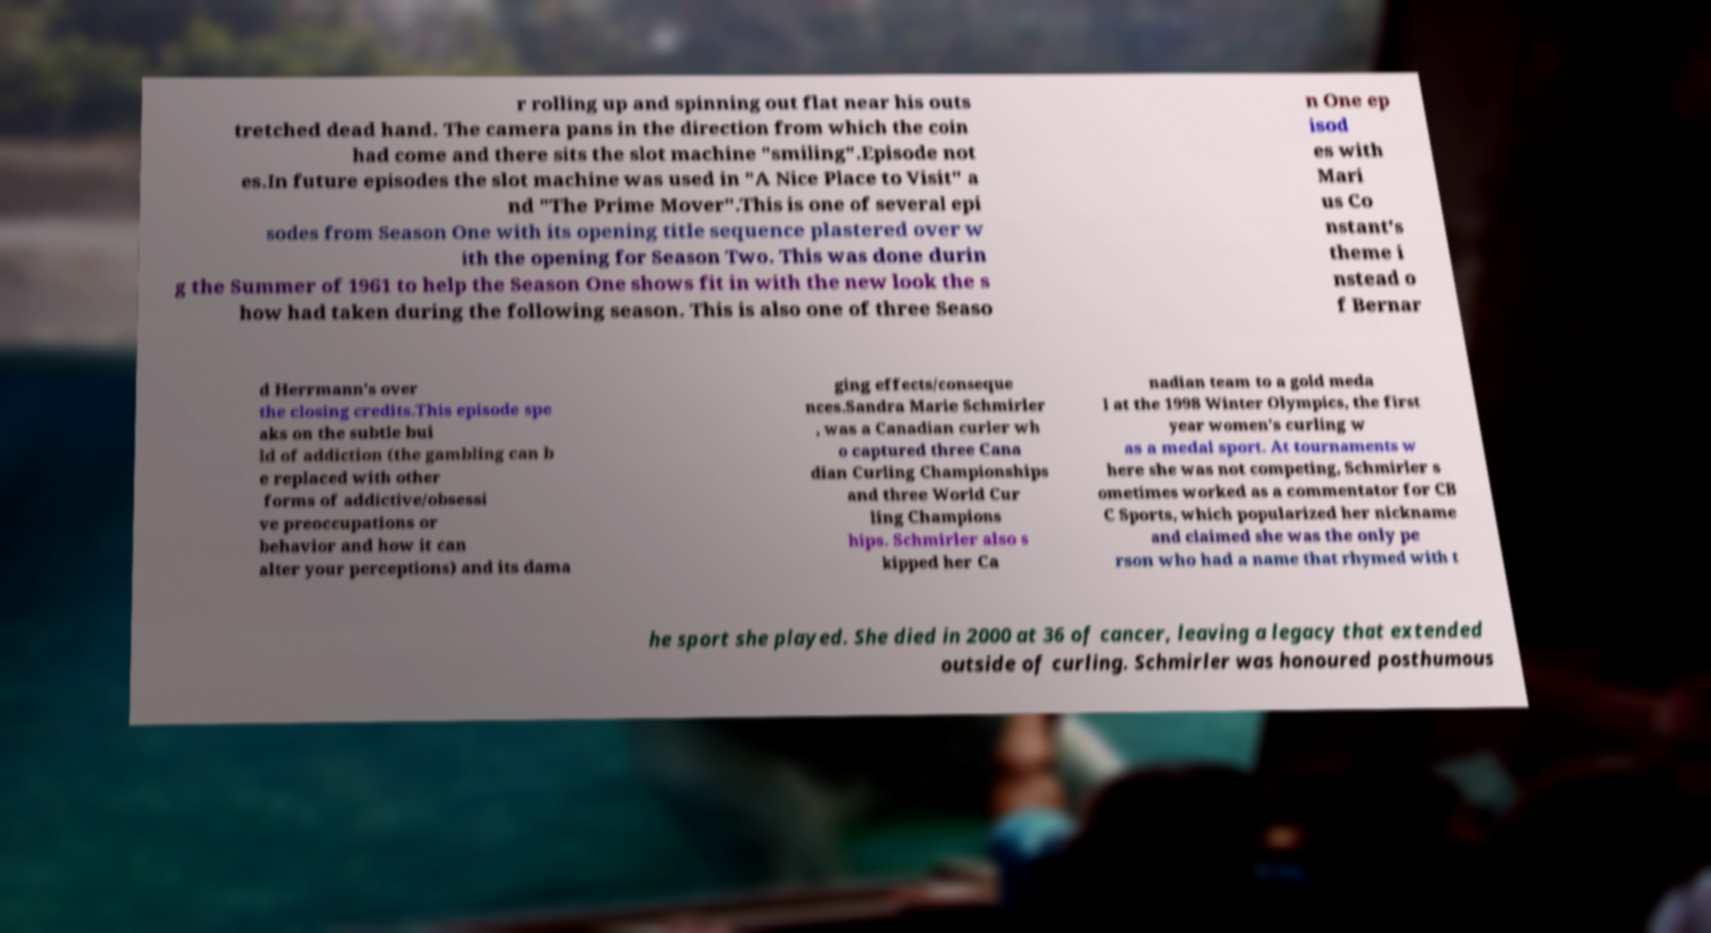Please identify and transcribe the text found in this image. r rolling up and spinning out flat near his outs tretched dead hand. The camera pans in the direction from which the coin had come and there sits the slot machine "smiling".Episode not es.In future episodes the slot machine was used in "A Nice Place to Visit" a nd "The Prime Mover".This is one of several epi sodes from Season One with its opening title sequence plastered over w ith the opening for Season Two. This was done durin g the Summer of 1961 to help the Season One shows fit in with the new look the s how had taken during the following season. This is also one of three Seaso n One ep isod es with Mari us Co nstant's theme i nstead o f Bernar d Herrmann's over the closing credits.This episode spe aks on the subtle bui ld of addiction (the gambling can b e replaced with other forms of addictive/obsessi ve preoccupations or behavior and how it can alter your perceptions) and its dama ging effects/conseque nces.Sandra Marie Schmirler , was a Canadian curler wh o captured three Cana dian Curling Championships and three World Cur ling Champions hips. Schmirler also s kipped her Ca nadian team to a gold meda l at the 1998 Winter Olympics, the first year women's curling w as a medal sport. At tournaments w here she was not competing, Schmirler s ometimes worked as a commentator for CB C Sports, which popularized her nickname and claimed she was the only pe rson who had a name that rhymed with t he sport she played. She died in 2000 at 36 of cancer, leaving a legacy that extended outside of curling. Schmirler was honoured posthumous 